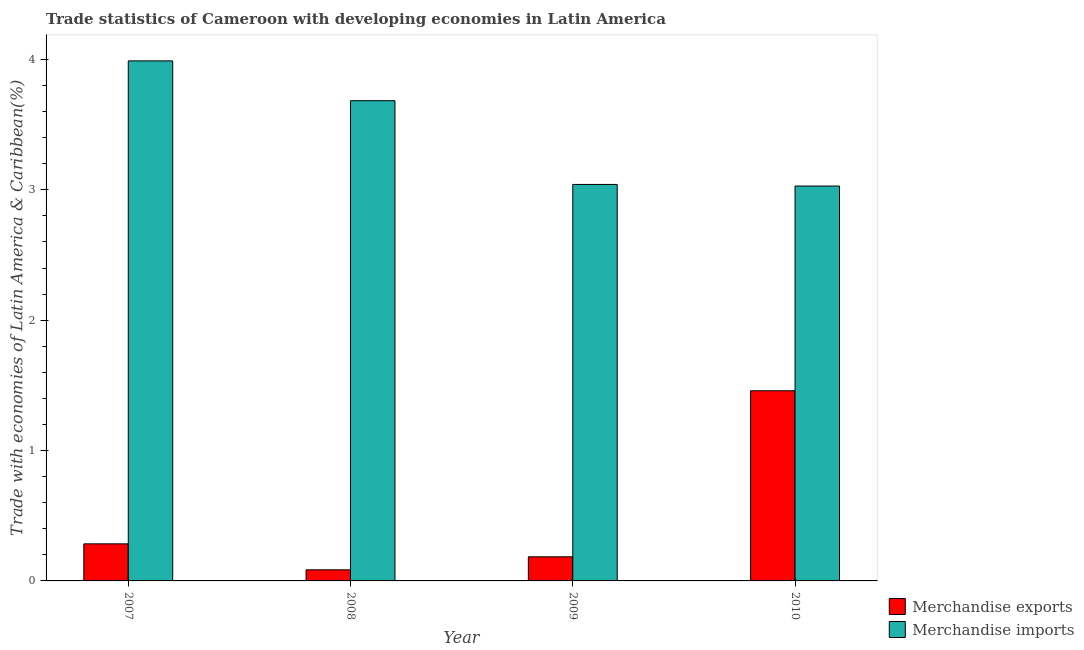Are the number of bars per tick equal to the number of legend labels?
Your response must be concise. Yes. How many bars are there on the 2nd tick from the right?
Give a very brief answer. 2. What is the label of the 4th group of bars from the left?
Provide a short and direct response. 2010. In how many cases, is the number of bars for a given year not equal to the number of legend labels?
Offer a very short reply. 0. What is the merchandise exports in 2008?
Provide a succinct answer. 0.09. Across all years, what is the maximum merchandise exports?
Provide a succinct answer. 1.46. Across all years, what is the minimum merchandise imports?
Offer a terse response. 3.03. In which year was the merchandise imports minimum?
Offer a terse response. 2010. What is the total merchandise exports in the graph?
Your answer should be very brief. 2.01. What is the difference between the merchandise exports in 2007 and that in 2009?
Give a very brief answer. 0.1. What is the difference between the merchandise imports in 2008 and the merchandise exports in 2010?
Your response must be concise. 0.65. What is the average merchandise exports per year?
Keep it short and to the point. 0.5. In the year 2009, what is the difference between the merchandise exports and merchandise imports?
Keep it short and to the point. 0. In how many years, is the merchandise exports greater than 0.6000000000000001 %?
Offer a very short reply. 1. What is the ratio of the merchandise exports in 2007 to that in 2008?
Provide a succinct answer. 3.34. What is the difference between the highest and the second highest merchandise exports?
Your answer should be very brief. 1.17. What is the difference between the highest and the lowest merchandise exports?
Give a very brief answer. 1.37. Is the sum of the merchandise exports in 2009 and 2010 greater than the maximum merchandise imports across all years?
Offer a very short reply. Yes. What does the 1st bar from the left in 2009 represents?
Offer a very short reply. Merchandise exports. Are all the bars in the graph horizontal?
Offer a terse response. No. How many years are there in the graph?
Keep it short and to the point. 4. Are the values on the major ticks of Y-axis written in scientific E-notation?
Offer a terse response. No. What is the title of the graph?
Keep it short and to the point. Trade statistics of Cameroon with developing economies in Latin America. Does "Register a property" appear as one of the legend labels in the graph?
Provide a short and direct response. No. What is the label or title of the X-axis?
Your answer should be very brief. Year. What is the label or title of the Y-axis?
Your response must be concise. Trade with economies of Latin America & Caribbean(%). What is the Trade with economies of Latin America & Caribbean(%) of Merchandise exports in 2007?
Provide a short and direct response. 0.28. What is the Trade with economies of Latin America & Caribbean(%) of Merchandise imports in 2007?
Keep it short and to the point. 3.99. What is the Trade with economies of Latin America & Caribbean(%) of Merchandise exports in 2008?
Your answer should be compact. 0.09. What is the Trade with economies of Latin America & Caribbean(%) of Merchandise imports in 2008?
Provide a short and direct response. 3.68. What is the Trade with economies of Latin America & Caribbean(%) of Merchandise exports in 2009?
Make the answer very short. 0.18. What is the Trade with economies of Latin America & Caribbean(%) in Merchandise imports in 2009?
Offer a terse response. 3.04. What is the Trade with economies of Latin America & Caribbean(%) of Merchandise exports in 2010?
Your answer should be compact. 1.46. What is the Trade with economies of Latin America & Caribbean(%) of Merchandise imports in 2010?
Your answer should be compact. 3.03. Across all years, what is the maximum Trade with economies of Latin America & Caribbean(%) of Merchandise exports?
Provide a short and direct response. 1.46. Across all years, what is the maximum Trade with economies of Latin America & Caribbean(%) in Merchandise imports?
Your answer should be very brief. 3.99. Across all years, what is the minimum Trade with economies of Latin America & Caribbean(%) in Merchandise exports?
Your response must be concise. 0.09. Across all years, what is the minimum Trade with economies of Latin America & Caribbean(%) in Merchandise imports?
Make the answer very short. 3.03. What is the total Trade with economies of Latin America & Caribbean(%) in Merchandise exports in the graph?
Ensure brevity in your answer.  2.01. What is the total Trade with economies of Latin America & Caribbean(%) in Merchandise imports in the graph?
Give a very brief answer. 13.74. What is the difference between the Trade with economies of Latin America & Caribbean(%) of Merchandise exports in 2007 and that in 2008?
Provide a succinct answer. 0.2. What is the difference between the Trade with economies of Latin America & Caribbean(%) in Merchandise imports in 2007 and that in 2008?
Keep it short and to the point. 0.31. What is the difference between the Trade with economies of Latin America & Caribbean(%) of Merchandise exports in 2007 and that in 2009?
Offer a very short reply. 0.1. What is the difference between the Trade with economies of Latin America & Caribbean(%) of Merchandise imports in 2007 and that in 2009?
Make the answer very short. 0.95. What is the difference between the Trade with economies of Latin America & Caribbean(%) in Merchandise exports in 2007 and that in 2010?
Provide a succinct answer. -1.17. What is the difference between the Trade with economies of Latin America & Caribbean(%) in Merchandise imports in 2007 and that in 2010?
Your answer should be very brief. 0.96. What is the difference between the Trade with economies of Latin America & Caribbean(%) in Merchandise exports in 2008 and that in 2009?
Ensure brevity in your answer.  -0.1. What is the difference between the Trade with economies of Latin America & Caribbean(%) in Merchandise imports in 2008 and that in 2009?
Make the answer very short. 0.64. What is the difference between the Trade with economies of Latin America & Caribbean(%) of Merchandise exports in 2008 and that in 2010?
Make the answer very short. -1.37. What is the difference between the Trade with economies of Latin America & Caribbean(%) in Merchandise imports in 2008 and that in 2010?
Make the answer very short. 0.65. What is the difference between the Trade with economies of Latin America & Caribbean(%) in Merchandise exports in 2009 and that in 2010?
Keep it short and to the point. -1.27. What is the difference between the Trade with economies of Latin America & Caribbean(%) of Merchandise imports in 2009 and that in 2010?
Offer a terse response. 0.01. What is the difference between the Trade with economies of Latin America & Caribbean(%) of Merchandise exports in 2007 and the Trade with economies of Latin America & Caribbean(%) of Merchandise imports in 2008?
Provide a succinct answer. -3.4. What is the difference between the Trade with economies of Latin America & Caribbean(%) of Merchandise exports in 2007 and the Trade with economies of Latin America & Caribbean(%) of Merchandise imports in 2009?
Your response must be concise. -2.76. What is the difference between the Trade with economies of Latin America & Caribbean(%) in Merchandise exports in 2007 and the Trade with economies of Latin America & Caribbean(%) in Merchandise imports in 2010?
Give a very brief answer. -2.74. What is the difference between the Trade with economies of Latin America & Caribbean(%) in Merchandise exports in 2008 and the Trade with economies of Latin America & Caribbean(%) in Merchandise imports in 2009?
Ensure brevity in your answer.  -2.96. What is the difference between the Trade with economies of Latin America & Caribbean(%) in Merchandise exports in 2008 and the Trade with economies of Latin America & Caribbean(%) in Merchandise imports in 2010?
Provide a short and direct response. -2.94. What is the difference between the Trade with economies of Latin America & Caribbean(%) of Merchandise exports in 2009 and the Trade with economies of Latin America & Caribbean(%) of Merchandise imports in 2010?
Give a very brief answer. -2.84. What is the average Trade with economies of Latin America & Caribbean(%) of Merchandise exports per year?
Provide a short and direct response. 0.5. What is the average Trade with economies of Latin America & Caribbean(%) of Merchandise imports per year?
Your response must be concise. 3.44. In the year 2007, what is the difference between the Trade with economies of Latin America & Caribbean(%) of Merchandise exports and Trade with economies of Latin America & Caribbean(%) of Merchandise imports?
Keep it short and to the point. -3.7. In the year 2008, what is the difference between the Trade with economies of Latin America & Caribbean(%) of Merchandise exports and Trade with economies of Latin America & Caribbean(%) of Merchandise imports?
Keep it short and to the point. -3.6. In the year 2009, what is the difference between the Trade with economies of Latin America & Caribbean(%) of Merchandise exports and Trade with economies of Latin America & Caribbean(%) of Merchandise imports?
Your answer should be very brief. -2.86. In the year 2010, what is the difference between the Trade with economies of Latin America & Caribbean(%) of Merchandise exports and Trade with economies of Latin America & Caribbean(%) of Merchandise imports?
Offer a very short reply. -1.57. What is the ratio of the Trade with economies of Latin America & Caribbean(%) of Merchandise exports in 2007 to that in 2008?
Ensure brevity in your answer.  3.34. What is the ratio of the Trade with economies of Latin America & Caribbean(%) in Merchandise imports in 2007 to that in 2008?
Provide a short and direct response. 1.08. What is the ratio of the Trade with economies of Latin America & Caribbean(%) in Merchandise exports in 2007 to that in 2009?
Provide a succinct answer. 1.54. What is the ratio of the Trade with economies of Latin America & Caribbean(%) in Merchandise imports in 2007 to that in 2009?
Provide a succinct answer. 1.31. What is the ratio of the Trade with economies of Latin America & Caribbean(%) in Merchandise exports in 2007 to that in 2010?
Provide a succinct answer. 0.19. What is the ratio of the Trade with economies of Latin America & Caribbean(%) of Merchandise imports in 2007 to that in 2010?
Provide a short and direct response. 1.32. What is the ratio of the Trade with economies of Latin America & Caribbean(%) in Merchandise exports in 2008 to that in 2009?
Give a very brief answer. 0.46. What is the ratio of the Trade with economies of Latin America & Caribbean(%) of Merchandise imports in 2008 to that in 2009?
Provide a succinct answer. 1.21. What is the ratio of the Trade with economies of Latin America & Caribbean(%) of Merchandise exports in 2008 to that in 2010?
Offer a terse response. 0.06. What is the ratio of the Trade with economies of Latin America & Caribbean(%) of Merchandise imports in 2008 to that in 2010?
Give a very brief answer. 1.22. What is the ratio of the Trade with economies of Latin America & Caribbean(%) in Merchandise exports in 2009 to that in 2010?
Offer a very short reply. 0.13. What is the difference between the highest and the second highest Trade with economies of Latin America & Caribbean(%) in Merchandise exports?
Offer a very short reply. 1.17. What is the difference between the highest and the second highest Trade with economies of Latin America & Caribbean(%) of Merchandise imports?
Offer a very short reply. 0.31. What is the difference between the highest and the lowest Trade with economies of Latin America & Caribbean(%) of Merchandise exports?
Provide a short and direct response. 1.37. What is the difference between the highest and the lowest Trade with economies of Latin America & Caribbean(%) of Merchandise imports?
Your answer should be compact. 0.96. 